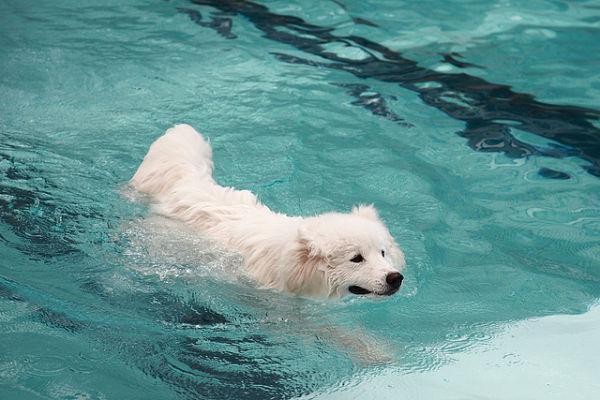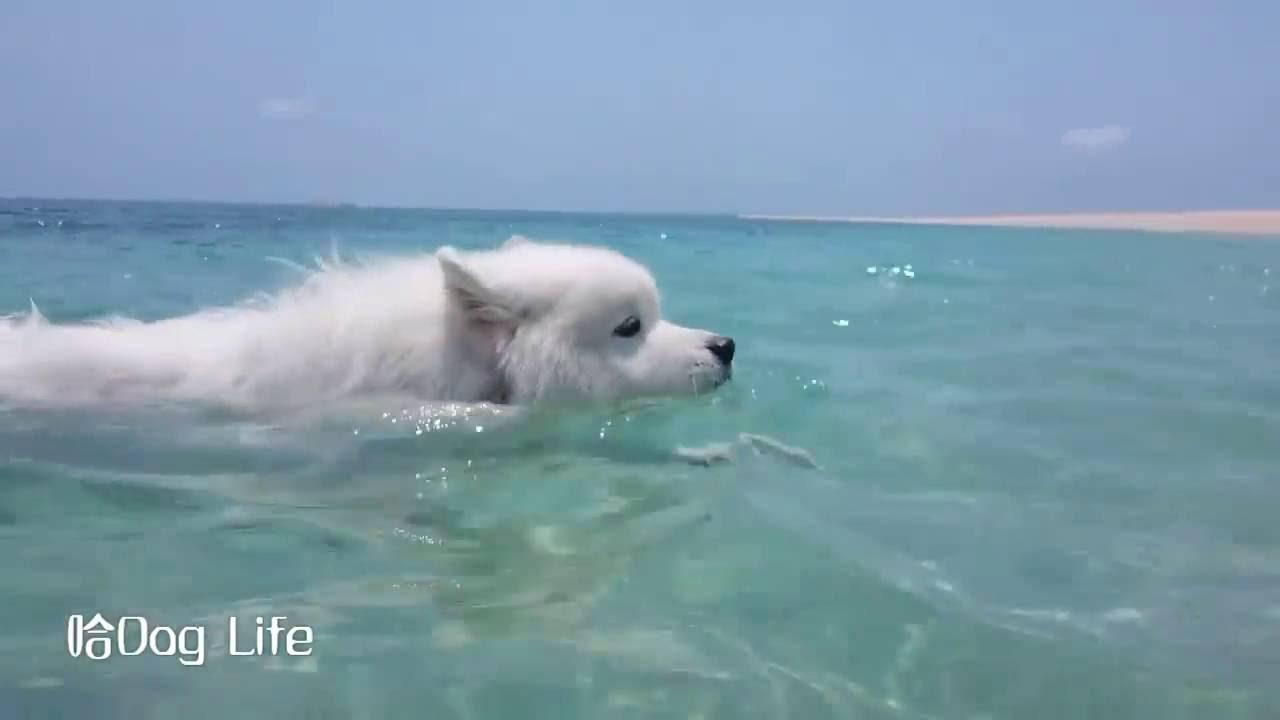The first image is the image on the left, the second image is the image on the right. For the images displayed, is the sentence "There is a dog swimming to the right in both images." factually correct? Answer yes or no. Yes. The first image is the image on the left, the second image is the image on the right. Examine the images to the left and right. Is the description "Both dogs are swimming in the water." accurate? Answer yes or no. Yes. 